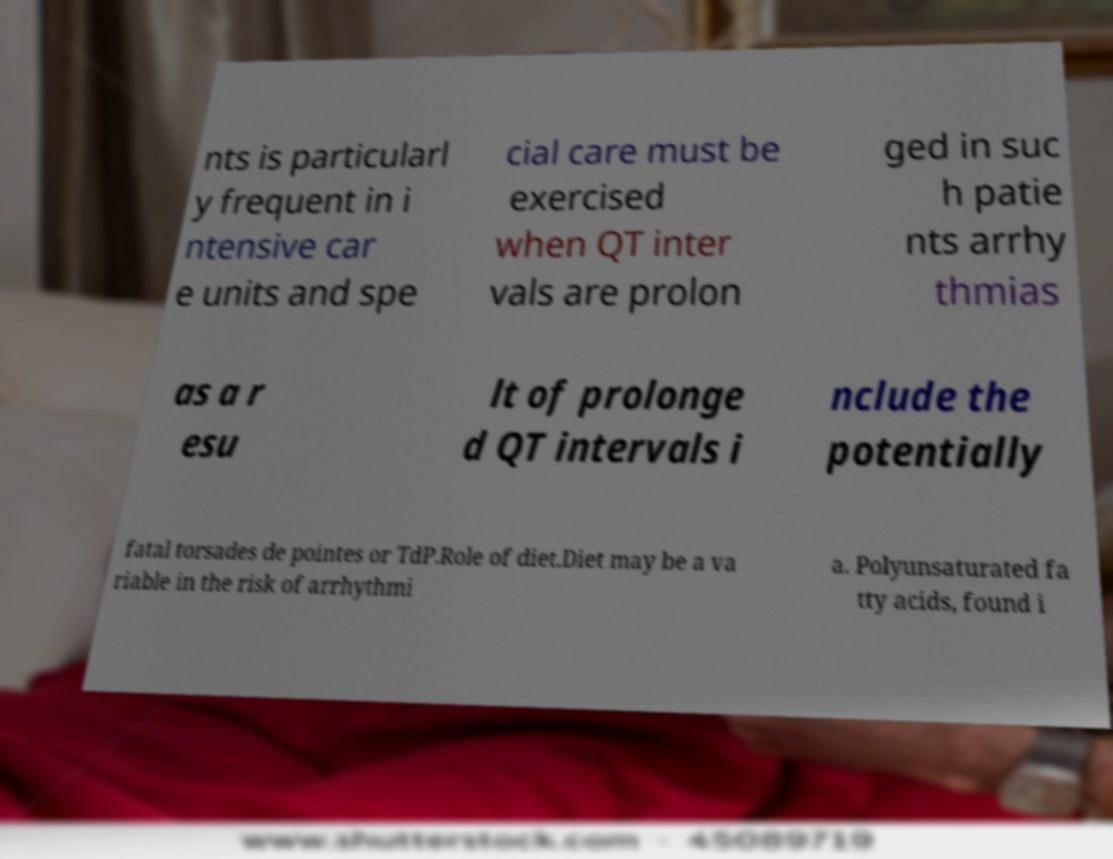I need the written content from this picture converted into text. Can you do that? nts is particularl y frequent in i ntensive car e units and spe cial care must be exercised when QT inter vals are prolon ged in suc h patie nts arrhy thmias as a r esu lt of prolonge d QT intervals i nclude the potentially fatal torsades de pointes or TdP.Role of diet.Diet may be a va riable in the risk of arrhythmi a. Polyunsaturated fa tty acids, found i 